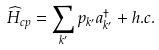<formula> <loc_0><loc_0><loc_500><loc_500>\widehat { H } _ { c p } = \sum _ { k ^ { \prime } } p _ { k ^ { \prime } } a _ { k ^ { \prime } } ^ { \dagger } + h . c .</formula> 